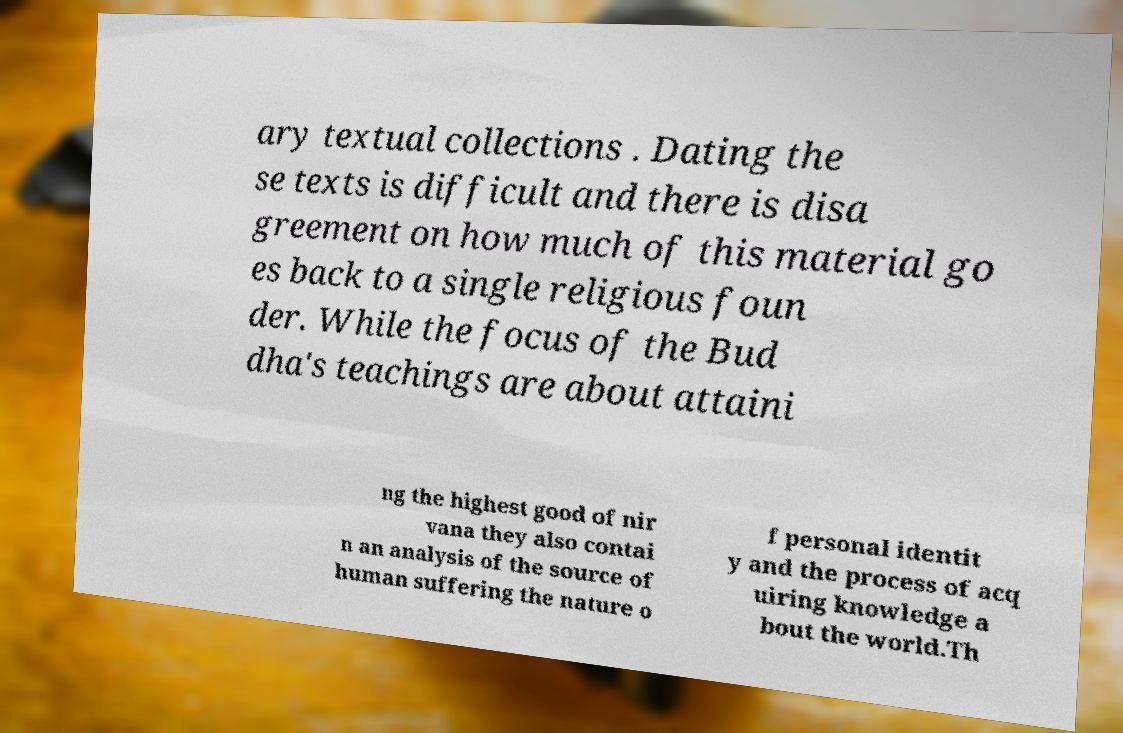What messages or text are displayed in this image? I need them in a readable, typed format. ary textual collections . Dating the se texts is difficult and there is disa greement on how much of this material go es back to a single religious foun der. While the focus of the Bud dha's teachings are about attaini ng the highest good of nir vana they also contai n an analysis of the source of human suffering the nature o f personal identit y and the process of acq uiring knowledge a bout the world.Th 